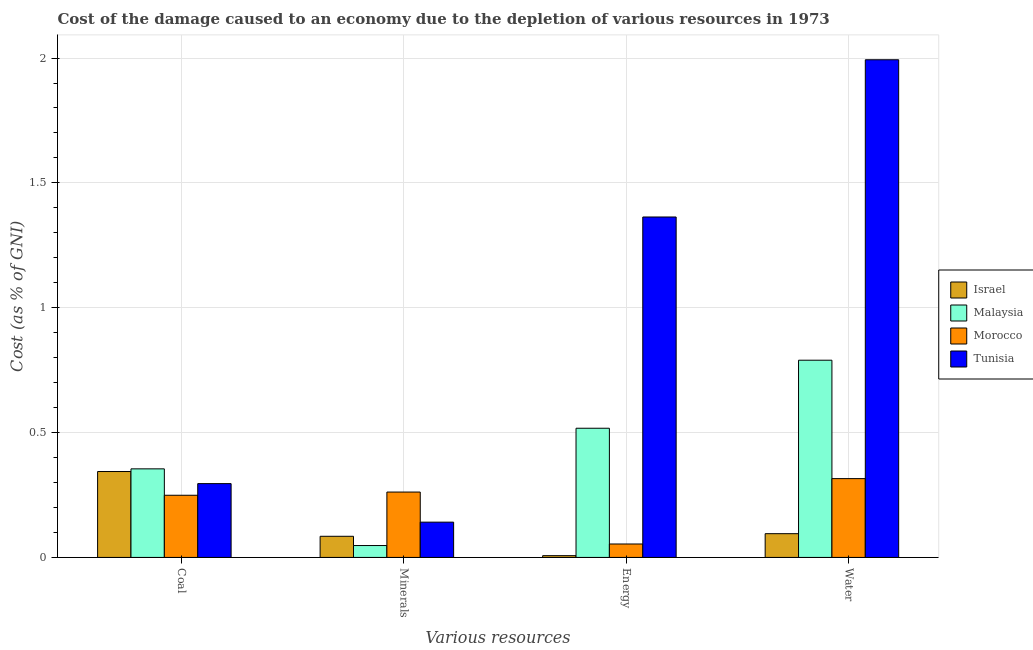How many bars are there on the 1st tick from the left?
Give a very brief answer. 4. What is the label of the 3rd group of bars from the left?
Offer a terse response. Energy. What is the cost of damage due to depletion of minerals in Tunisia?
Make the answer very short. 0.14. Across all countries, what is the maximum cost of damage due to depletion of coal?
Ensure brevity in your answer.  0.35. Across all countries, what is the minimum cost of damage due to depletion of minerals?
Offer a terse response. 0.05. In which country was the cost of damage due to depletion of energy maximum?
Keep it short and to the point. Tunisia. In which country was the cost of damage due to depletion of coal minimum?
Your response must be concise. Morocco. What is the total cost of damage due to depletion of minerals in the graph?
Keep it short and to the point. 0.54. What is the difference between the cost of damage due to depletion of energy in Tunisia and that in Morocco?
Provide a succinct answer. 1.31. What is the difference between the cost of damage due to depletion of coal in Malaysia and the cost of damage due to depletion of energy in Tunisia?
Make the answer very short. -1.01. What is the average cost of damage due to depletion of water per country?
Ensure brevity in your answer.  0.8. What is the difference between the cost of damage due to depletion of water and cost of damage due to depletion of energy in Israel?
Your answer should be very brief. 0.09. In how many countries, is the cost of damage due to depletion of minerals greater than 1.4 %?
Your answer should be compact. 0. What is the ratio of the cost of damage due to depletion of energy in Tunisia to that in Malaysia?
Your answer should be very brief. 2.64. What is the difference between the highest and the second highest cost of damage due to depletion of minerals?
Your answer should be compact. 0.12. What is the difference between the highest and the lowest cost of damage due to depletion of water?
Give a very brief answer. 1.9. Is the sum of the cost of damage due to depletion of energy in Malaysia and Israel greater than the maximum cost of damage due to depletion of coal across all countries?
Make the answer very short. Yes. What does the 3rd bar from the left in Coal represents?
Offer a terse response. Morocco. How many bars are there?
Give a very brief answer. 16. How many countries are there in the graph?
Give a very brief answer. 4. Are the values on the major ticks of Y-axis written in scientific E-notation?
Keep it short and to the point. No. Does the graph contain grids?
Provide a succinct answer. Yes. How many legend labels are there?
Make the answer very short. 4. What is the title of the graph?
Your answer should be very brief. Cost of the damage caused to an economy due to the depletion of various resources in 1973 . What is the label or title of the X-axis?
Your answer should be compact. Various resources. What is the label or title of the Y-axis?
Your answer should be compact. Cost (as % of GNI). What is the Cost (as % of GNI) of Israel in Coal?
Provide a succinct answer. 0.34. What is the Cost (as % of GNI) in Malaysia in Coal?
Give a very brief answer. 0.35. What is the Cost (as % of GNI) in Morocco in Coal?
Offer a terse response. 0.25. What is the Cost (as % of GNI) of Tunisia in Coal?
Your answer should be very brief. 0.3. What is the Cost (as % of GNI) in Israel in Minerals?
Offer a very short reply. 0.08. What is the Cost (as % of GNI) of Malaysia in Minerals?
Make the answer very short. 0.05. What is the Cost (as % of GNI) of Morocco in Minerals?
Keep it short and to the point. 0.26. What is the Cost (as % of GNI) in Tunisia in Minerals?
Keep it short and to the point. 0.14. What is the Cost (as % of GNI) of Israel in Energy?
Offer a terse response. 0.01. What is the Cost (as % of GNI) in Malaysia in Energy?
Give a very brief answer. 0.52. What is the Cost (as % of GNI) of Morocco in Energy?
Offer a terse response. 0.05. What is the Cost (as % of GNI) in Tunisia in Energy?
Provide a short and direct response. 1.36. What is the Cost (as % of GNI) in Israel in Water?
Your answer should be compact. 0.1. What is the Cost (as % of GNI) of Malaysia in Water?
Give a very brief answer. 0.79. What is the Cost (as % of GNI) in Morocco in Water?
Offer a very short reply. 0.32. What is the Cost (as % of GNI) in Tunisia in Water?
Keep it short and to the point. 1.99. Across all Various resources, what is the maximum Cost (as % of GNI) in Israel?
Offer a terse response. 0.34. Across all Various resources, what is the maximum Cost (as % of GNI) of Malaysia?
Offer a very short reply. 0.79. Across all Various resources, what is the maximum Cost (as % of GNI) in Morocco?
Provide a succinct answer. 0.32. Across all Various resources, what is the maximum Cost (as % of GNI) in Tunisia?
Your answer should be compact. 1.99. Across all Various resources, what is the minimum Cost (as % of GNI) in Israel?
Make the answer very short. 0.01. Across all Various resources, what is the minimum Cost (as % of GNI) of Malaysia?
Your response must be concise. 0.05. Across all Various resources, what is the minimum Cost (as % of GNI) in Morocco?
Make the answer very short. 0.05. Across all Various resources, what is the minimum Cost (as % of GNI) in Tunisia?
Offer a very short reply. 0.14. What is the total Cost (as % of GNI) in Israel in the graph?
Your response must be concise. 0.53. What is the total Cost (as % of GNI) in Malaysia in the graph?
Ensure brevity in your answer.  1.71. What is the total Cost (as % of GNI) in Morocco in the graph?
Your answer should be very brief. 0.88. What is the total Cost (as % of GNI) of Tunisia in the graph?
Offer a very short reply. 3.79. What is the difference between the Cost (as % of GNI) in Israel in Coal and that in Minerals?
Ensure brevity in your answer.  0.26. What is the difference between the Cost (as % of GNI) in Malaysia in Coal and that in Minerals?
Make the answer very short. 0.31. What is the difference between the Cost (as % of GNI) in Morocco in Coal and that in Minerals?
Offer a very short reply. -0.01. What is the difference between the Cost (as % of GNI) of Tunisia in Coal and that in Minerals?
Your answer should be compact. 0.15. What is the difference between the Cost (as % of GNI) in Israel in Coal and that in Energy?
Offer a very short reply. 0.34. What is the difference between the Cost (as % of GNI) in Malaysia in Coal and that in Energy?
Provide a succinct answer. -0.16. What is the difference between the Cost (as % of GNI) of Morocco in Coal and that in Energy?
Offer a terse response. 0.2. What is the difference between the Cost (as % of GNI) of Tunisia in Coal and that in Energy?
Keep it short and to the point. -1.07. What is the difference between the Cost (as % of GNI) of Israel in Coal and that in Water?
Offer a very short reply. 0.25. What is the difference between the Cost (as % of GNI) of Malaysia in Coal and that in Water?
Offer a very short reply. -0.44. What is the difference between the Cost (as % of GNI) in Morocco in Coal and that in Water?
Make the answer very short. -0.07. What is the difference between the Cost (as % of GNI) in Tunisia in Coal and that in Water?
Provide a succinct answer. -1.7. What is the difference between the Cost (as % of GNI) of Israel in Minerals and that in Energy?
Your answer should be compact. 0.08. What is the difference between the Cost (as % of GNI) in Malaysia in Minerals and that in Energy?
Provide a succinct answer. -0.47. What is the difference between the Cost (as % of GNI) of Morocco in Minerals and that in Energy?
Your response must be concise. 0.21. What is the difference between the Cost (as % of GNI) in Tunisia in Minerals and that in Energy?
Keep it short and to the point. -1.22. What is the difference between the Cost (as % of GNI) in Israel in Minerals and that in Water?
Keep it short and to the point. -0.01. What is the difference between the Cost (as % of GNI) in Malaysia in Minerals and that in Water?
Give a very brief answer. -0.74. What is the difference between the Cost (as % of GNI) of Morocco in Minerals and that in Water?
Offer a very short reply. -0.05. What is the difference between the Cost (as % of GNI) of Tunisia in Minerals and that in Water?
Make the answer very short. -1.85. What is the difference between the Cost (as % of GNI) in Israel in Energy and that in Water?
Provide a short and direct response. -0.09. What is the difference between the Cost (as % of GNI) of Malaysia in Energy and that in Water?
Offer a terse response. -0.27. What is the difference between the Cost (as % of GNI) in Morocco in Energy and that in Water?
Give a very brief answer. -0.26. What is the difference between the Cost (as % of GNI) of Tunisia in Energy and that in Water?
Provide a short and direct response. -0.63. What is the difference between the Cost (as % of GNI) in Israel in Coal and the Cost (as % of GNI) in Malaysia in Minerals?
Your answer should be compact. 0.3. What is the difference between the Cost (as % of GNI) in Israel in Coal and the Cost (as % of GNI) in Morocco in Minerals?
Give a very brief answer. 0.08. What is the difference between the Cost (as % of GNI) in Israel in Coal and the Cost (as % of GNI) in Tunisia in Minerals?
Ensure brevity in your answer.  0.2. What is the difference between the Cost (as % of GNI) of Malaysia in Coal and the Cost (as % of GNI) of Morocco in Minerals?
Ensure brevity in your answer.  0.09. What is the difference between the Cost (as % of GNI) in Malaysia in Coal and the Cost (as % of GNI) in Tunisia in Minerals?
Make the answer very short. 0.21. What is the difference between the Cost (as % of GNI) in Morocco in Coal and the Cost (as % of GNI) in Tunisia in Minerals?
Provide a short and direct response. 0.11. What is the difference between the Cost (as % of GNI) of Israel in Coal and the Cost (as % of GNI) of Malaysia in Energy?
Give a very brief answer. -0.17. What is the difference between the Cost (as % of GNI) of Israel in Coal and the Cost (as % of GNI) of Morocco in Energy?
Offer a terse response. 0.29. What is the difference between the Cost (as % of GNI) in Israel in Coal and the Cost (as % of GNI) in Tunisia in Energy?
Provide a short and direct response. -1.02. What is the difference between the Cost (as % of GNI) in Malaysia in Coal and the Cost (as % of GNI) in Morocco in Energy?
Your response must be concise. 0.3. What is the difference between the Cost (as % of GNI) of Malaysia in Coal and the Cost (as % of GNI) of Tunisia in Energy?
Your answer should be compact. -1.01. What is the difference between the Cost (as % of GNI) in Morocco in Coal and the Cost (as % of GNI) in Tunisia in Energy?
Make the answer very short. -1.11. What is the difference between the Cost (as % of GNI) in Israel in Coal and the Cost (as % of GNI) in Malaysia in Water?
Make the answer very short. -0.45. What is the difference between the Cost (as % of GNI) of Israel in Coal and the Cost (as % of GNI) of Morocco in Water?
Provide a succinct answer. 0.03. What is the difference between the Cost (as % of GNI) in Israel in Coal and the Cost (as % of GNI) in Tunisia in Water?
Give a very brief answer. -1.65. What is the difference between the Cost (as % of GNI) of Malaysia in Coal and the Cost (as % of GNI) of Morocco in Water?
Your answer should be compact. 0.04. What is the difference between the Cost (as % of GNI) in Malaysia in Coal and the Cost (as % of GNI) in Tunisia in Water?
Your answer should be very brief. -1.64. What is the difference between the Cost (as % of GNI) in Morocco in Coal and the Cost (as % of GNI) in Tunisia in Water?
Ensure brevity in your answer.  -1.74. What is the difference between the Cost (as % of GNI) in Israel in Minerals and the Cost (as % of GNI) in Malaysia in Energy?
Offer a very short reply. -0.43. What is the difference between the Cost (as % of GNI) of Israel in Minerals and the Cost (as % of GNI) of Morocco in Energy?
Provide a short and direct response. 0.03. What is the difference between the Cost (as % of GNI) in Israel in Minerals and the Cost (as % of GNI) in Tunisia in Energy?
Offer a very short reply. -1.28. What is the difference between the Cost (as % of GNI) of Malaysia in Minerals and the Cost (as % of GNI) of Morocco in Energy?
Make the answer very short. -0.01. What is the difference between the Cost (as % of GNI) of Malaysia in Minerals and the Cost (as % of GNI) of Tunisia in Energy?
Provide a short and direct response. -1.32. What is the difference between the Cost (as % of GNI) in Morocco in Minerals and the Cost (as % of GNI) in Tunisia in Energy?
Ensure brevity in your answer.  -1.1. What is the difference between the Cost (as % of GNI) in Israel in Minerals and the Cost (as % of GNI) in Malaysia in Water?
Ensure brevity in your answer.  -0.71. What is the difference between the Cost (as % of GNI) of Israel in Minerals and the Cost (as % of GNI) of Morocco in Water?
Make the answer very short. -0.23. What is the difference between the Cost (as % of GNI) of Israel in Minerals and the Cost (as % of GNI) of Tunisia in Water?
Keep it short and to the point. -1.91. What is the difference between the Cost (as % of GNI) in Malaysia in Minerals and the Cost (as % of GNI) in Morocco in Water?
Make the answer very short. -0.27. What is the difference between the Cost (as % of GNI) in Malaysia in Minerals and the Cost (as % of GNI) in Tunisia in Water?
Make the answer very short. -1.95. What is the difference between the Cost (as % of GNI) in Morocco in Minerals and the Cost (as % of GNI) in Tunisia in Water?
Give a very brief answer. -1.73. What is the difference between the Cost (as % of GNI) in Israel in Energy and the Cost (as % of GNI) in Malaysia in Water?
Provide a short and direct response. -0.78. What is the difference between the Cost (as % of GNI) of Israel in Energy and the Cost (as % of GNI) of Morocco in Water?
Ensure brevity in your answer.  -0.31. What is the difference between the Cost (as % of GNI) of Israel in Energy and the Cost (as % of GNI) of Tunisia in Water?
Keep it short and to the point. -1.99. What is the difference between the Cost (as % of GNI) of Malaysia in Energy and the Cost (as % of GNI) of Morocco in Water?
Make the answer very short. 0.2. What is the difference between the Cost (as % of GNI) of Malaysia in Energy and the Cost (as % of GNI) of Tunisia in Water?
Your response must be concise. -1.48. What is the difference between the Cost (as % of GNI) in Morocco in Energy and the Cost (as % of GNI) in Tunisia in Water?
Keep it short and to the point. -1.94. What is the average Cost (as % of GNI) of Israel per Various resources?
Your answer should be compact. 0.13. What is the average Cost (as % of GNI) of Malaysia per Various resources?
Your answer should be very brief. 0.43. What is the average Cost (as % of GNI) in Morocco per Various resources?
Provide a short and direct response. 0.22. What is the average Cost (as % of GNI) in Tunisia per Various resources?
Offer a very short reply. 0.95. What is the difference between the Cost (as % of GNI) in Israel and Cost (as % of GNI) in Malaysia in Coal?
Your answer should be compact. -0.01. What is the difference between the Cost (as % of GNI) in Israel and Cost (as % of GNI) in Morocco in Coal?
Provide a short and direct response. 0.1. What is the difference between the Cost (as % of GNI) in Israel and Cost (as % of GNI) in Tunisia in Coal?
Your answer should be compact. 0.05. What is the difference between the Cost (as % of GNI) of Malaysia and Cost (as % of GNI) of Morocco in Coal?
Provide a short and direct response. 0.11. What is the difference between the Cost (as % of GNI) of Malaysia and Cost (as % of GNI) of Tunisia in Coal?
Give a very brief answer. 0.06. What is the difference between the Cost (as % of GNI) of Morocco and Cost (as % of GNI) of Tunisia in Coal?
Keep it short and to the point. -0.05. What is the difference between the Cost (as % of GNI) of Israel and Cost (as % of GNI) of Malaysia in Minerals?
Make the answer very short. 0.04. What is the difference between the Cost (as % of GNI) in Israel and Cost (as % of GNI) in Morocco in Minerals?
Provide a short and direct response. -0.18. What is the difference between the Cost (as % of GNI) of Israel and Cost (as % of GNI) of Tunisia in Minerals?
Offer a very short reply. -0.06. What is the difference between the Cost (as % of GNI) in Malaysia and Cost (as % of GNI) in Morocco in Minerals?
Your response must be concise. -0.21. What is the difference between the Cost (as % of GNI) of Malaysia and Cost (as % of GNI) of Tunisia in Minerals?
Offer a terse response. -0.09. What is the difference between the Cost (as % of GNI) in Morocco and Cost (as % of GNI) in Tunisia in Minerals?
Your response must be concise. 0.12. What is the difference between the Cost (as % of GNI) of Israel and Cost (as % of GNI) of Malaysia in Energy?
Offer a terse response. -0.51. What is the difference between the Cost (as % of GNI) of Israel and Cost (as % of GNI) of Morocco in Energy?
Provide a short and direct response. -0.05. What is the difference between the Cost (as % of GNI) of Israel and Cost (as % of GNI) of Tunisia in Energy?
Give a very brief answer. -1.36. What is the difference between the Cost (as % of GNI) of Malaysia and Cost (as % of GNI) of Morocco in Energy?
Your response must be concise. 0.46. What is the difference between the Cost (as % of GNI) in Malaysia and Cost (as % of GNI) in Tunisia in Energy?
Provide a succinct answer. -0.85. What is the difference between the Cost (as % of GNI) in Morocco and Cost (as % of GNI) in Tunisia in Energy?
Offer a terse response. -1.31. What is the difference between the Cost (as % of GNI) in Israel and Cost (as % of GNI) in Malaysia in Water?
Provide a succinct answer. -0.69. What is the difference between the Cost (as % of GNI) of Israel and Cost (as % of GNI) of Morocco in Water?
Your answer should be very brief. -0.22. What is the difference between the Cost (as % of GNI) in Israel and Cost (as % of GNI) in Tunisia in Water?
Give a very brief answer. -1.9. What is the difference between the Cost (as % of GNI) of Malaysia and Cost (as % of GNI) of Morocco in Water?
Keep it short and to the point. 0.47. What is the difference between the Cost (as % of GNI) of Malaysia and Cost (as % of GNI) of Tunisia in Water?
Provide a succinct answer. -1.2. What is the difference between the Cost (as % of GNI) of Morocco and Cost (as % of GNI) of Tunisia in Water?
Your answer should be compact. -1.68. What is the ratio of the Cost (as % of GNI) of Israel in Coal to that in Minerals?
Offer a terse response. 4.06. What is the ratio of the Cost (as % of GNI) in Malaysia in Coal to that in Minerals?
Your answer should be compact. 7.45. What is the ratio of the Cost (as % of GNI) in Morocco in Coal to that in Minerals?
Make the answer very short. 0.95. What is the ratio of the Cost (as % of GNI) in Tunisia in Coal to that in Minerals?
Your response must be concise. 2.09. What is the ratio of the Cost (as % of GNI) of Israel in Coal to that in Energy?
Make the answer very short. 48.75. What is the ratio of the Cost (as % of GNI) in Malaysia in Coal to that in Energy?
Make the answer very short. 0.69. What is the ratio of the Cost (as % of GNI) in Morocco in Coal to that in Energy?
Keep it short and to the point. 4.63. What is the ratio of the Cost (as % of GNI) of Tunisia in Coal to that in Energy?
Your response must be concise. 0.22. What is the ratio of the Cost (as % of GNI) in Israel in Coal to that in Water?
Your answer should be very brief. 3.62. What is the ratio of the Cost (as % of GNI) of Malaysia in Coal to that in Water?
Your answer should be compact. 0.45. What is the ratio of the Cost (as % of GNI) of Morocco in Coal to that in Water?
Provide a succinct answer. 0.79. What is the ratio of the Cost (as % of GNI) in Tunisia in Coal to that in Water?
Offer a very short reply. 0.15. What is the ratio of the Cost (as % of GNI) of Israel in Minerals to that in Energy?
Ensure brevity in your answer.  12. What is the ratio of the Cost (as % of GNI) in Malaysia in Minerals to that in Energy?
Give a very brief answer. 0.09. What is the ratio of the Cost (as % of GNI) of Morocco in Minerals to that in Energy?
Ensure brevity in your answer.  4.87. What is the ratio of the Cost (as % of GNI) in Tunisia in Minerals to that in Energy?
Make the answer very short. 0.1. What is the ratio of the Cost (as % of GNI) of Israel in Minerals to that in Water?
Offer a very short reply. 0.89. What is the ratio of the Cost (as % of GNI) in Malaysia in Minerals to that in Water?
Make the answer very short. 0.06. What is the ratio of the Cost (as % of GNI) in Morocco in Minerals to that in Water?
Provide a short and direct response. 0.83. What is the ratio of the Cost (as % of GNI) of Tunisia in Minerals to that in Water?
Provide a short and direct response. 0.07. What is the ratio of the Cost (as % of GNI) in Israel in Energy to that in Water?
Provide a short and direct response. 0.07. What is the ratio of the Cost (as % of GNI) of Malaysia in Energy to that in Water?
Your answer should be very brief. 0.66. What is the ratio of the Cost (as % of GNI) in Morocco in Energy to that in Water?
Your answer should be compact. 0.17. What is the ratio of the Cost (as % of GNI) in Tunisia in Energy to that in Water?
Ensure brevity in your answer.  0.68. What is the difference between the highest and the second highest Cost (as % of GNI) in Israel?
Your response must be concise. 0.25. What is the difference between the highest and the second highest Cost (as % of GNI) of Malaysia?
Keep it short and to the point. 0.27. What is the difference between the highest and the second highest Cost (as % of GNI) of Morocco?
Offer a very short reply. 0.05. What is the difference between the highest and the second highest Cost (as % of GNI) of Tunisia?
Give a very brief answer. 0.63. What is the difference between the highest and the lowest Cost (as % of GNI) of Israel?
Give a very brief answer. 0.34. What is the difference between the highest and the lowest Cost (as % of GNI) of Malaysia?
Offer a very short reply. 0.74. What is the difference between the highest and the lowest Cost (as % of GNI) of Morocco?
Ensure brevity in your answer.  0.26. What is the difference between the highest and the lowest Cost (as % of GNI) of Tunisia?
Your response must be concise. 1.85. 